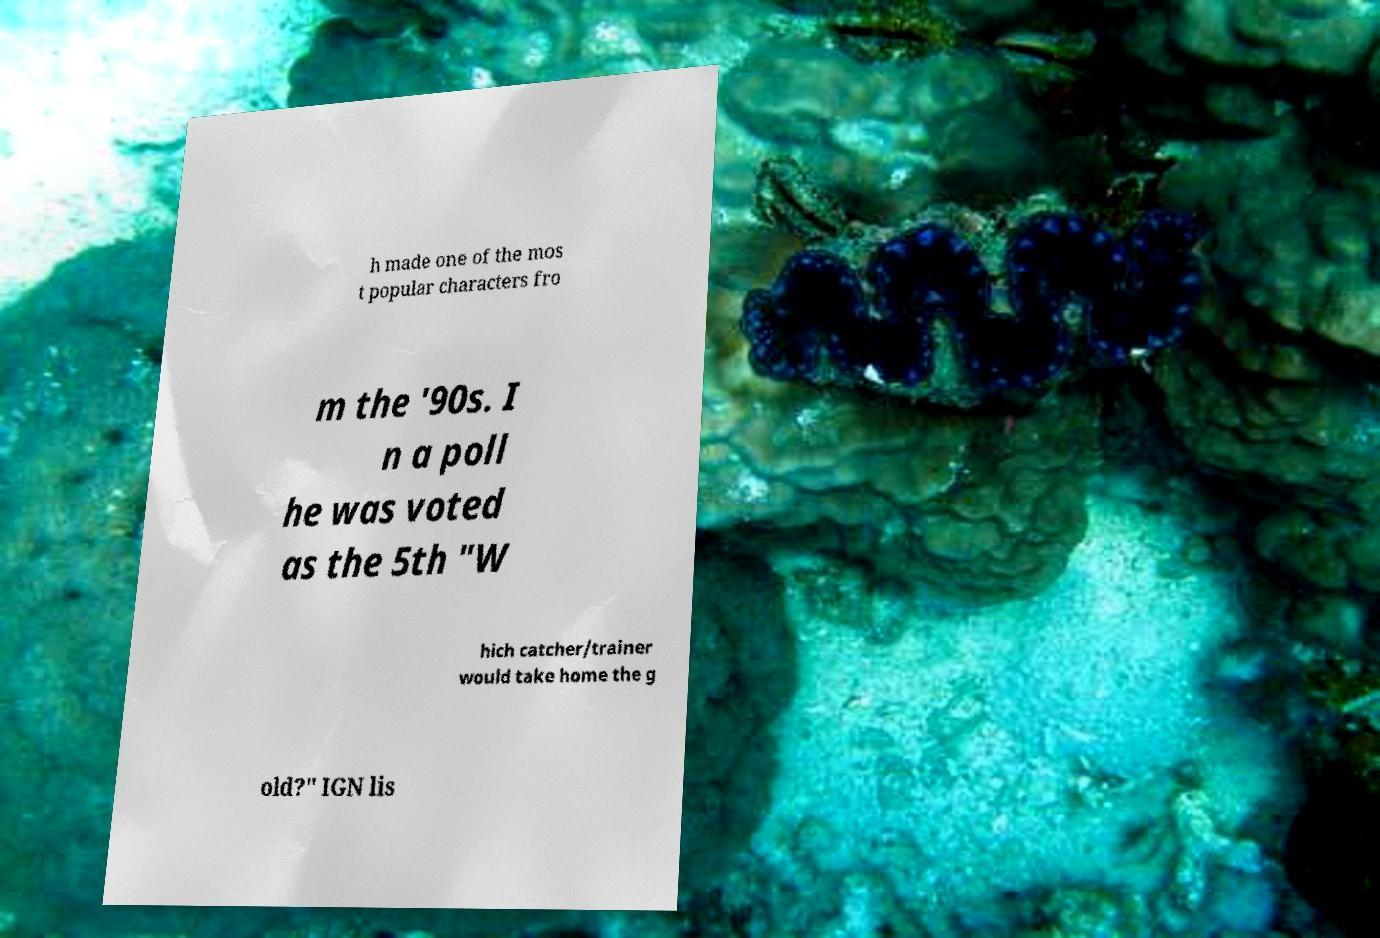Can you read and provide the text displayed in the image?This photo seems to have some interesting text. Can you extract and type it out for me? h made one of the mos t popular characters fro m the '90s. I n a poll he was voted as the 5th "W hich catcher/trainer would take home the g old?" IGN lis 